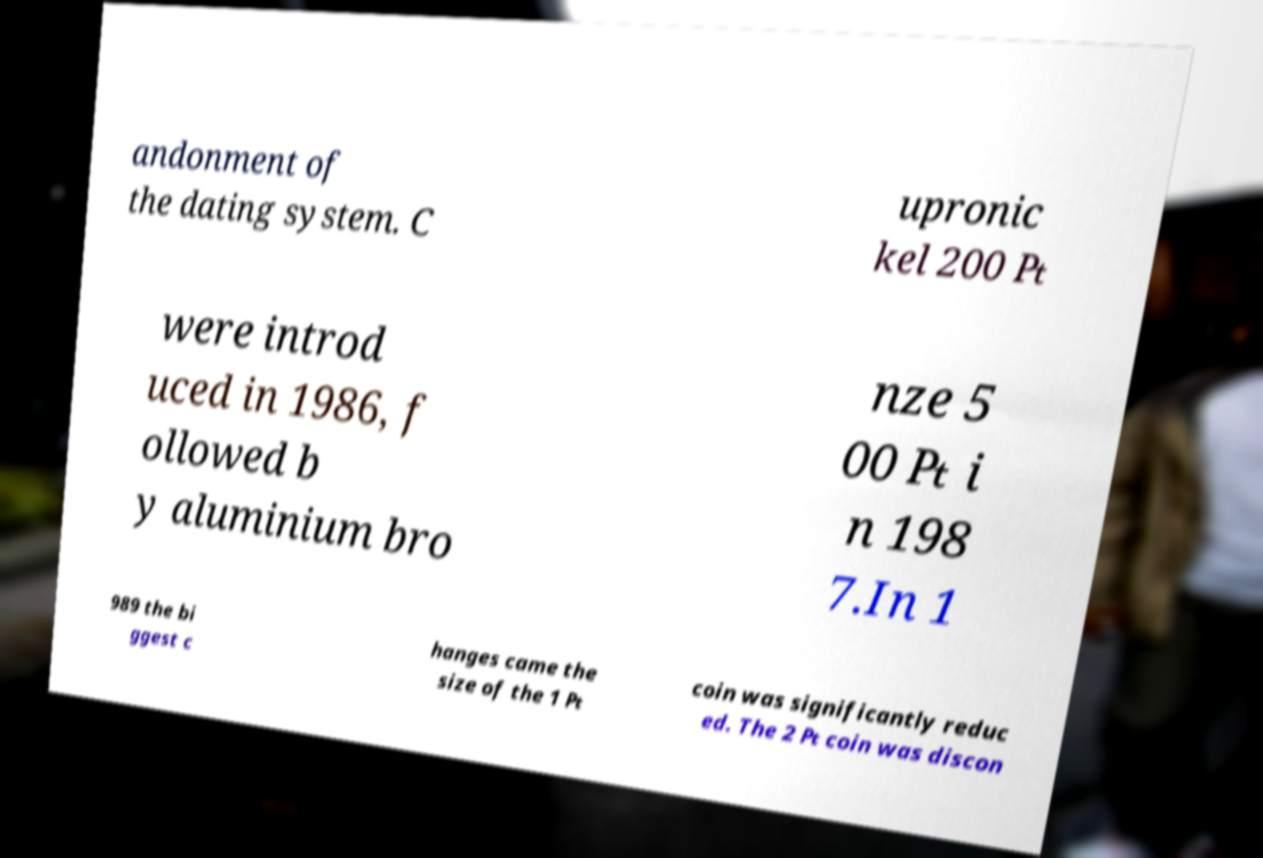Please read and relay the text visible in this image. What does it say? andonment of the dating system. C upronic kel 200 ₧ were introd uced in 1986, f ollowed b y aluminium bro nze 5 00 ₧ i n 198 7.In 1 989 the bi ggest c hanges came the size of the 1 ₧ coin was significantly reduc ed. The 2 ₧ coin was discon 